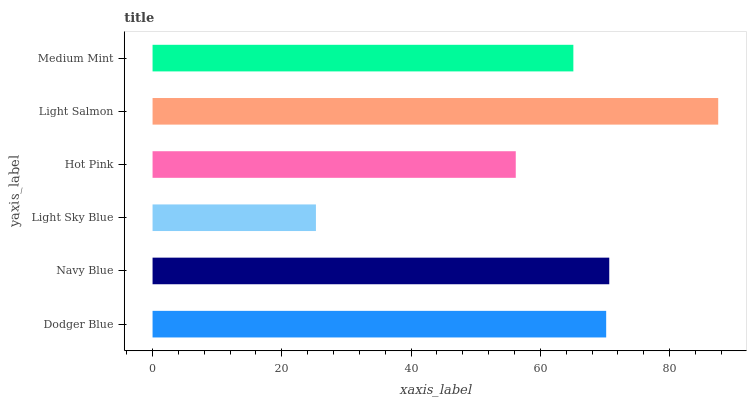Is Light Sky Blue the minimum?
Answer yes or no. Yes. Is Light Salmon the maximum?
Answer yes or no. Yes. Is Navy Blue the minimum?
Answer yes or no. No. Is Navy Blue the maximum?
Answer yes or no. No. Is Navy Blue greater than Dodger Blue?
Answer yes or no. Yes. Is Dodger Blue less than Navy Blue?
Answer yes or no. Yes. Is Dodger Blue greater than Navy Blue?
Answer yes or no. No. Is Navy Blue less than Dodger Blue?
Answer yes or no. No. Is Dodger Blue the high median?
Answer yes or no. Yes. Is Medium Mint the low median?
Answer yes or no. Yes. Is Light Salmon the high median?
Answer yes or no. No. Is Light Sky Blue the low median?
Answer yes or no. No. 